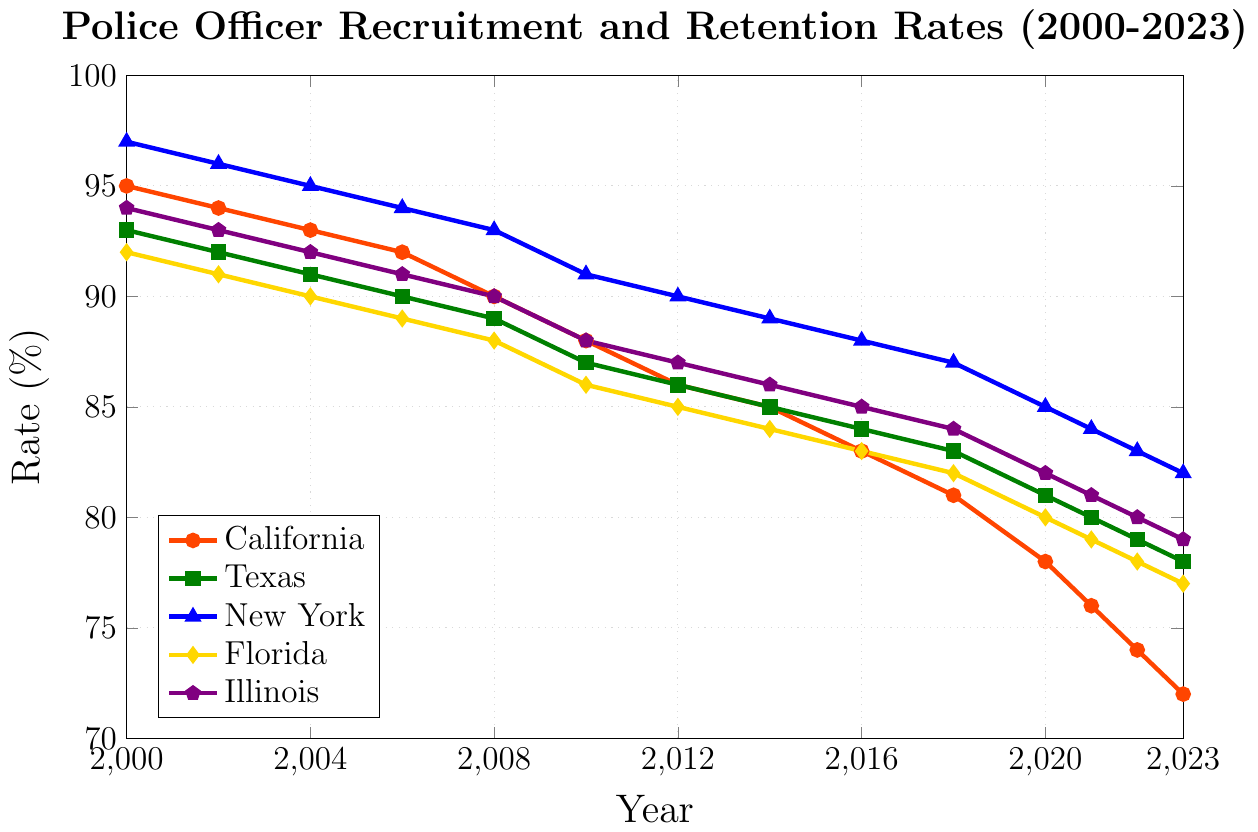Which state had the highest recruitment and retention rate in 2000? To find the state with the highest rate in 2000, look at the rates for all states in that year. New York has the highest at 97%.
Answer: New York How did the recruitment rate for California change from 2000 to 2023? Identify the rates for California in 2000 and 2023, then calculate the difference. The rate drops from 95% in 2000 to 72% in 2023, a decrease of 23%.
Answer: Decreased by 23% Which state's recruitment rate decreased the least from 2000 to 2023? Compare the changes in recruitment rates from 2000 to 2023 for each state. Texas had a decrease from 93% to 78%, a change of 15%, which is the smallest decrease among all states.
Answer: Texas What is the average recruitment rate for Florida between 2010 and 2023? Find the rates for Florida from 2010 to 2023: 86, 85, 84, 83, 82, 80, 79, 78, and 77. Sum these values and divide by the number of data points. The average is (86 + 85 + 84 + 83 + 82 + 80 + 79 + 78 + 77) / 9 = 82.7.
Answer: 82.7 Between which consecutive years did New York see the largest decrease in recruitment rate? Observe the recruitment rates for New York across the years and calculate the differences between each pair of consecutive years. The largest decrease is between 2000 and 2002, from 97% to 96%, but there is another significant decrease from 2020 to 2021, where it decreases from 85% to 84%. They are both equal changes of 1%.
Answer: 2000-2002 and 2020-2021 In which year did Illinois have the same recruitment rate as Texas? Check the recruitment rates for both Illinois and Texas each year. In 2021, both states have a recruitment rate of 81%.
Answer: 2021 What is the total decrease in recruitment rate for Florida from 2000 to 2023? Florida's rate in 2000 is 92%, and in 2023 it is 77%. The total decrease is 92% - 77% = 15%.
Answer: 15% Compare the recruitment rates in 2016 between California and New York, and identify which state had a higher rate and by how much. California's recruitment rate in 2016 is 83%, while New York’s is 88%. New York had a higher rate by 88% - 83% = 5%.
Answer: New York by 5% What is the median recruitment rate for Texas from 2000 to 2023? List Texas' recruitment rates from 2000 to 2023: 93, 92, 91, 90, 89, 87, 86, 85, 84, 83, 81, 80, 79, 78. The median is the middle value in this sorted list, which is 86.
Answer: 86 